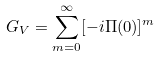<formula> <loc_0><loc_0><loc_500><loc_500>G _ { V } = \sum _ { m = 0 } ^ { \infty } [ - i \Pi ( 0 ) ] ^ { m }</formula> 